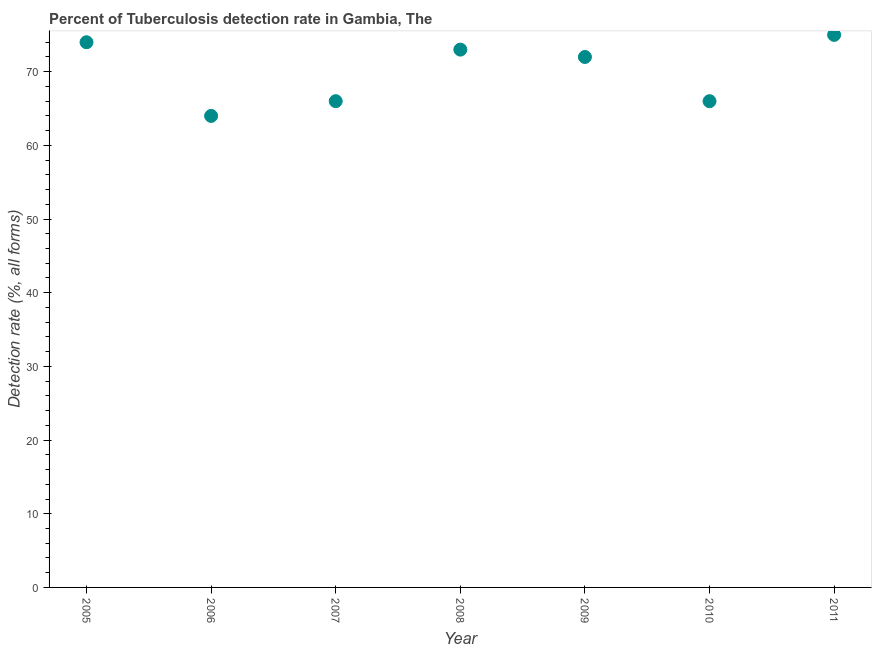What is the detection rate of tuberculosis in 2006?
Keep it short and to the point. 64. Across all years, what is the maximum detection rate of tuberculosis?
Provide a succinct answer. 75. Across all years, what is the minimum detection rate of tuberculosis?
Provide a succinct answer. 64. What is the sum of the detection rate of tuberculosis?
Offer a terse response. 490. What is the difference between the detection rate of tuberculosis in 2008 and 2009?
Your answer should be compact. 1. What is the average detection rate of tuberculosis per year?
Your answer should be compact. 70. What is the median detection rate of tuberculosis?
Ensure brevity in your answer.  72. What is the ratio of the detection rate of tuberculosis in 2007 to that in 2008?
Make the answer very short. 0.9. Is the difference between the detection rate of tuberculosis in 2007 and 2009 greater than the difference between any two years?
Make the answer very short. No. Is the sum of the detection rate of tuberculosis in 2007 and 2010 greater than the maximum detection rate of tuberculosis across all years?
Your answer should be very brief. Yes. What is the difference between the highest and the lowest detection rate of tuberculosis?
Your response must be concise. 11. How many dotlines are there?
Your answer should be compact. 1. Are the values on the major ticks of Y-axis written in scientific E-notation?
Offer a very short reply. No. Does the graph contain any zero values?
Keep it short and to the point. No. Does the graph contain grids?
Offer a terse response. No. What is the title of the graph?
Give a very brief answer. Percent of Tuberculosis detection rate in Gambia, The. What is the label or title of the Y-axis?
Ensure brevity in your answer.  Detection rate (%, all forms). What is the Detection rate (%, all forms) in 2007?
Your answer should be very brief. 66. What is the difference between the Detection rate (%, all forms) in 2005 and 2007?
Your response must be concise. 8. What is the difference between the Detection rate (%, all forms) in 2005 and 2009?
Offer a very short reply. 2. What is the difference between the Detection rate (%, all forms) in 2005 and 2011?
Your answer should be compact. -1. What is the difference between the Detection rate (%, all forms) in 2006 and 2007?
Provide a short and direct response. -2. What is the difference between the Detection rate (%, all forms) in 2006 and 2009?
Offer a terse response. -8. What is the difference between the Detection rate (%, all forms) in 2006 and 2010?
Offer a terse response. -2. What is the difference between the Detection rate (%, all forms) in 2007 and 2010?
Keep it short and to the point. 0. What is the difference between the Detection rate (%, all forms) in 2008 and 2009?
Provide a short and direct response. 1. What is the difference between the Detection rate (%, all forms) in 2008 and 2011?
Provide a short and direct response. -2. What is the difference between the Detection rate (%, all forms) in 2009 and 2010?
Give a very brief answer. 6. What is the difference between the Detection rate (%, all forms) in 2009 and 2011?
Keep it short and to the point. -3. What is the difference between the Detection rate (%, all forms) in 2010 and 2011?
Your answer should be compact. -9. What is the ratio of the Detection rate (%, all forms) in 2005 to that in 2006?
Your answer should be very brief. 1.16. What is the ratio of the Detection rate (%, all forms) in 2005 to that in 2007?
Provide a succinct answer. 1.12. What is the ratio of the Detection rate (%, all forms) in 2005 to that in 2008?
Provide a short and direct response. 1.01. What is the ratio of the Detection rate (%, all forms) in 2005 to that in 2009?
Your response must be concise. 1.03. What is the ratio of the Detection rate (%, all forms) in 2005 to that in 2010?
Your answer should be very brief. 1.12. What is the ratio of the Detection rate (%, all forms) in 2006 to that in 2008?
Ensure brevity in your answer.  0.88. What is the ratio of the Detection rate (%, all forms) in 2006 to that in 2009?
Keep it short and to the point. 0.89. What is the ratio of the Detection rate (%, all forms) in 2006 to that in 2010?
Your answer should be compact. 0.97. What is the ratio of the Detection rate (%, all forms) in 2006 to that in 2011?
Make the answer very short. 0.85. What is the ratio of the Detection rate (%, all forms) in 2007 to that in 2008?
Offer a very short reply. 0.9. What is the ratio of the Detection rate (%, all forms) in 2007 to that in 2009?
Your response must be concise. 0.92. What is the ratio of the Detection rate (%, all forms) in 2007 to that in 2011?
Offer a very short reply. 0.88. What is the ratio of the Detection rate (%, all forms) in 2008 to that in 2009?
Provide a short and direct response. 1.01. What is the ratio of the Detection rate (%, all forms) in 2008 to that in 2010?
Ensure brevity in your answer.  1.11. What is the ratio of the Detection rate (%, all forms) in 2009 to that in 2010?
Provide a short and direct response. 1.09. What is the ratio of the Detection rate (%, all forms) in 2009 to that in 2011?
Provide a short and direct response. 0.96. What is the ratio of the Detection rate (%, all forms) in 2010 to that in 2011?
Offer a very short reply. 0.88. 